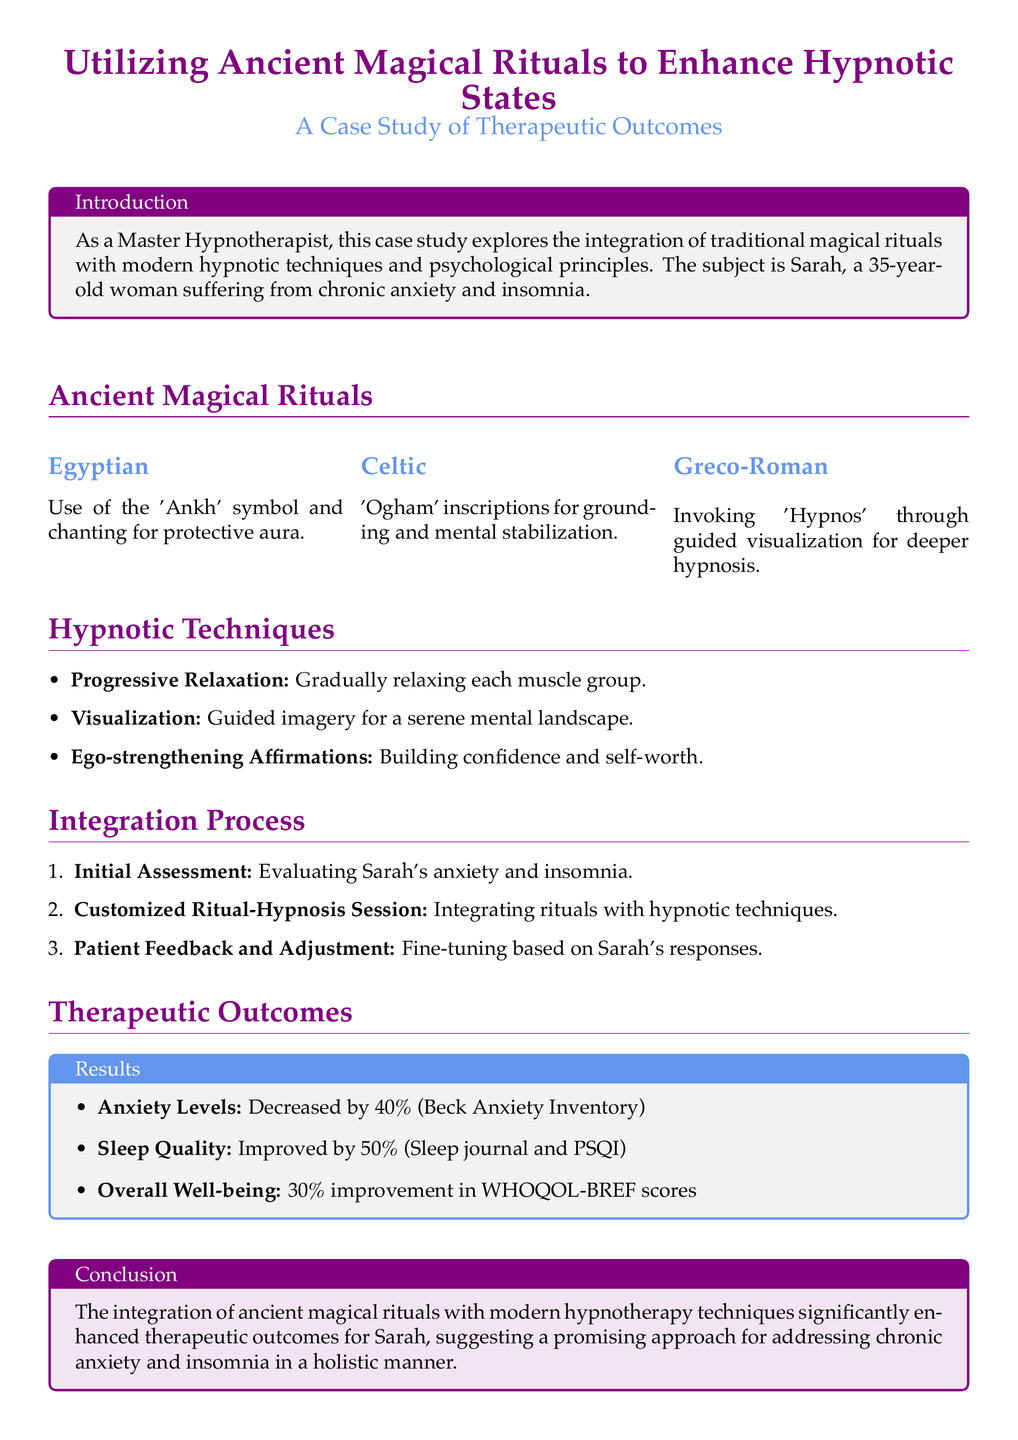What age is the subject Sarah? Sarah is a 35-year-old woman, as mentioned in the introduction of the case study.
Answer: 35 What symbol is used in the Egyptian magical ritual? The 'Ankh' symbol is employed for creating a protective aura.
Answer: Ankh By what percentage did anxiety levels decrease? The document states that anxiety levels decreased by 40% as per the Beck Anxiety Inventory.
Answer: 40% What is the improvement percentage in sleep quality? The improvement in sleep quality is documented to be 50% based on the sleep journal and PSQI.
Answer: 50% Which questionnaire was used to assess overall well-being? The WHOQOL-BREF scores were used to evaluate overall well-being.
Answer: WHOQOL-BREF What technique is used for building confidence? Ego-strengthening Affirmations are utilized to enhance confidence and self-worth.
Answer: Ego-strengthening Affirmations What type of assessment was performed initially? An Initial Assessment was conducted to evaluate Sarah's anxiety and insomnia levels.
Answer: Initial Assessment What ancient culture's rituals were involved in grounding? The Celtic rituals involved 'Ogham' inscriptions for grounding and mental stabilization.
Answer: Celtic What was the overall improvement percentage in well-being? The overall well-being showed a 30% improvement, according to the document.
Answer: 30% 